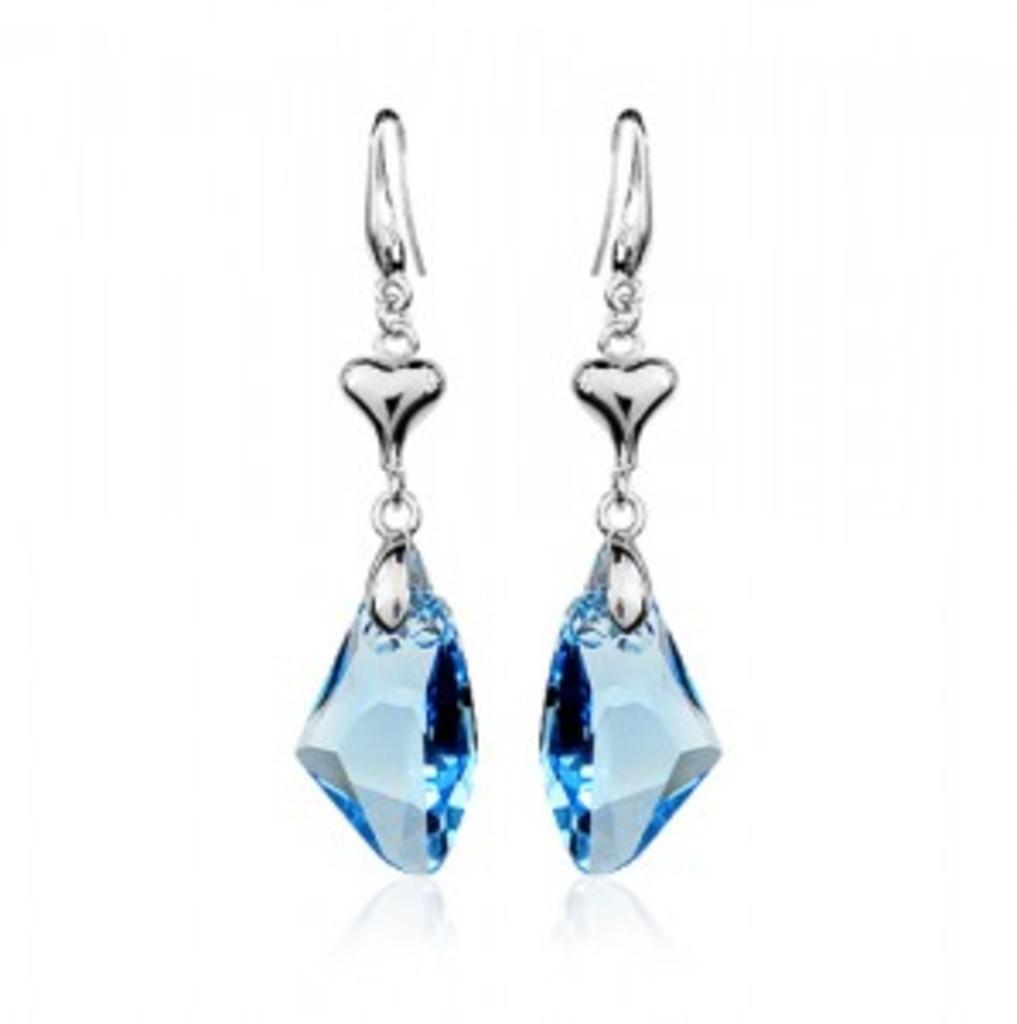What is the main subject of the image? The main subject of the image is a pair of earrings. What type of books can be seen on the table next to the earrings in the image? There are no books present in the image; it only features a pair of earrings. 